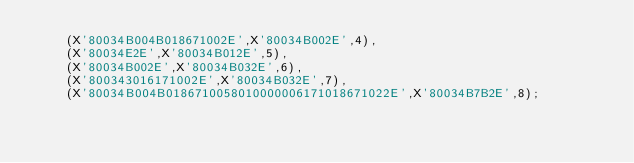Convert code to text. <code><loc_0><loc_0><loc_500><loc_500><_SQL_>    (X'80034B004B018671002E',X'80034B002E',4),
    (X'80034E2E',X'80034B012E',5),
    (X'80034B002E',X'80034B032E',6),
    (X'800343016171002E',X'80034B032E',7),
    (X'80034B004B0186710058010000006171018671022E',X'80034B7B2E',8);</code> 